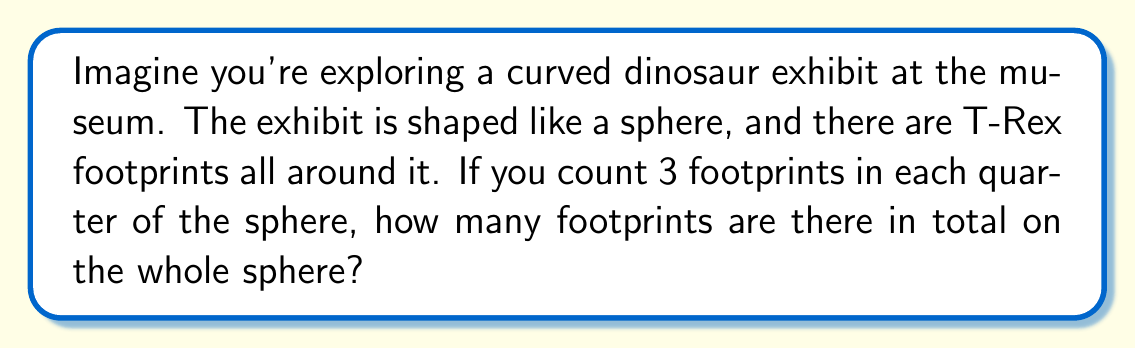Could you help me with this problem? Let's break this down step by step:

1. First, we need to understand what a sphere looks like. It's like a big ball, just like the Earth!

2. The question tells us that the sphere is divided into quarters. A sphere has 4 quarters, just like an orange cut into 4 pieces.

3. We're told that there are 3 footprints in each quarter. Let's count that:
   - Quarter 1: 3 footprints
   - Quarter 2: 3 footprints
   - Quarter 3: 3 footprints
   - Quarter 4: 3 footprints

4. Now, we need to add up all the footprints. We can use multiplication to make this easier:
   $$ \text{Total footprints} = \text{Footprints per quarter} \times \text{Number of quarters} $$
   $$ \text{Total footprints} = 3 \times 4 = 12 $$

So, there are 12 footprints in total on the whole sphere.
Answer: 12 footprints 